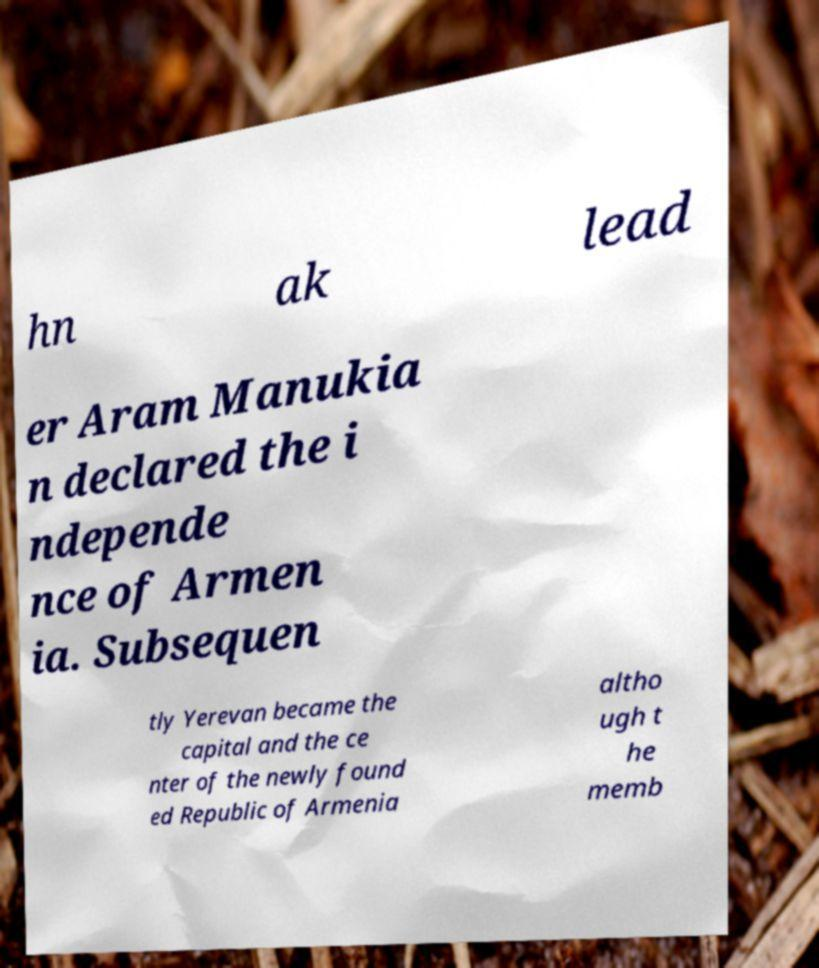Please identify and transcribe the text found in this image. hn ak lead er Aram Manukia n declared the i ndepende nce of Armen ia. Subsequen tly Yerevan became the capital and the ce nter of the newly found ed Republic of Armenia altho ugh t he memb 